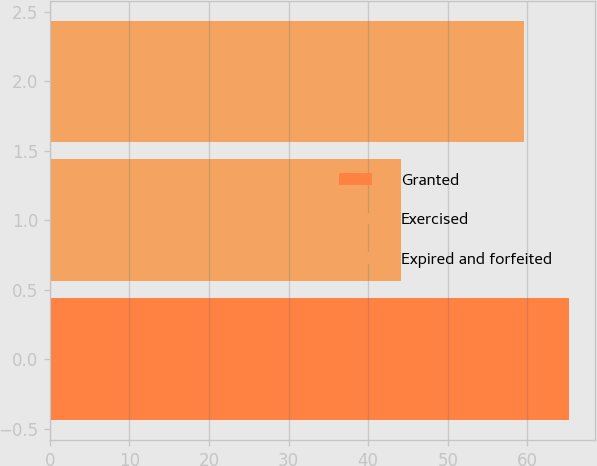Convert chart to OTSL. <chart><loc_0><loc_0><loc_500><loc_500><bar_chart><fcel>Granted<fcel>Exercised<fcel>Expired and forfeited<nl><fcel>65.26<fcel>44.08<fcel>59.55<nl></chart> 